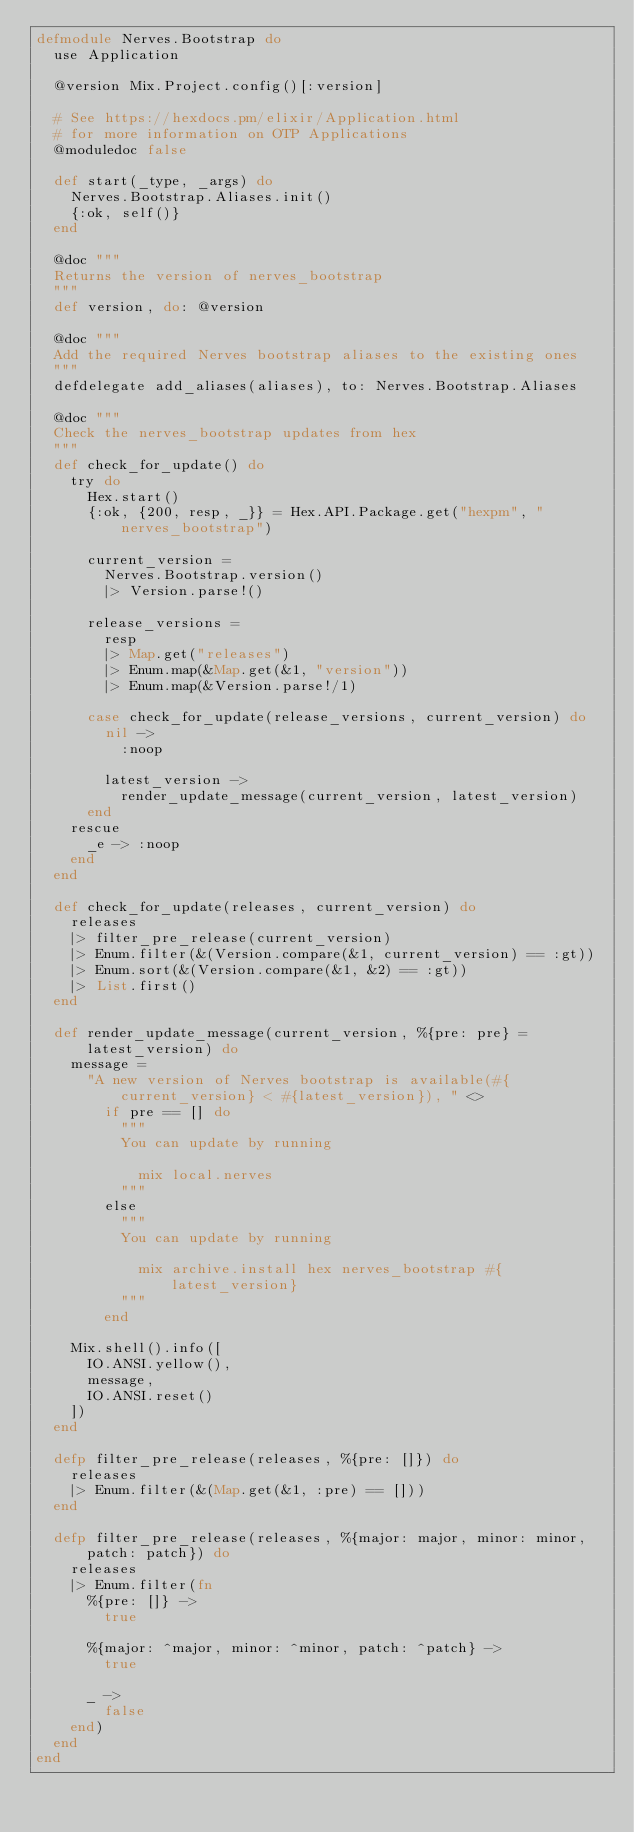<code> <loc_0><loc_0><loc_500><loc_500><_Elixir_>defmodule Nerves.Bootstrap do
  use Application

  @version Mix.Project.config()[:version]

  # See https://hexdocs.pm/elixir/Application.html
  # for more information on OTP Applications
  @moduledoc false

  def start(_type, _args) do
    Nerves.Bootstrap.Aliases.init()
    {:ok, self()}
  end

  @doc """
  Returns the version of nerves_bootstrap
  """
  def version, do: @version

  @doc """
  Add the required Nerves bootstrap aliases to the existing ones
  """
  defdelegate add_aliases(aliases), to: Nerves.Bootstrap.Aliases

  @doc """
  Check the nerves_bootstrap updates from hex
  """
  def check_for_update() do
    try do
      Hex.start()
      {:ok, {200, resp, _}} = Hex.API.Package.get("hexpm", "nerves_bootstrap")

      current_version =
        Nerves.Bootstrap.version()
        |> Version.parse!()

      release_versions =
        resp
        |> Map.get("releases")
        |> Enum.map(&Map.get(&1, "version"))
        |> Enum.map(&Version.parse!/1)

      case check_for_update(release_versions, current_version) do
        nil ->
          :noop

        latest_version ->
          render_update_message(current_version, latest_version)
      end
    rescue
      _e -> :noop
    end
  end

  def check_for_update(releases, current_version) do
    releases
    |> filter_pre_release(current_version)
    |> Enum.filter(&(Version.compare(&1, current_version) == :gt))
    |> Enum.sort(&(Version.compare(&1, &2) == :gt))
    |> List.first()
  end

  def render_update_message(current_version, %{pre: pre} = latest_version) do
    message =
      "A new version of Nerves bootstrap is available(#{current_version} < #{latest_version}), " <>
        if pre == [] do
          """
          You can update by running
            
            mix local.nerves
          """
        else
          """
          You can update by running
            
            mix archive.install hex nerves_bootstrap #{latest_version}
          """
        end

    Mix.shell().info([
      IO.ANSI.yellow(),
      message,
      IO.ANSI.reset()
    ])
  end

  defp filter_pre_release(releases, %{pre: []}) do
    releases
    |> Enum.filter(&(Map.get(&1, :pre) == []))
  end

  defp filter_pre_release(releases, %{major: major, minor: minor, patch: patch}) do
    releases
    |> Enum.filter(fn
      %{pre: []} ->
        true

      %{major: ^major, minor: ^minor, patch: ^patch} ->
        true

      _ ->
        false
    end)
  end
end
</code> 